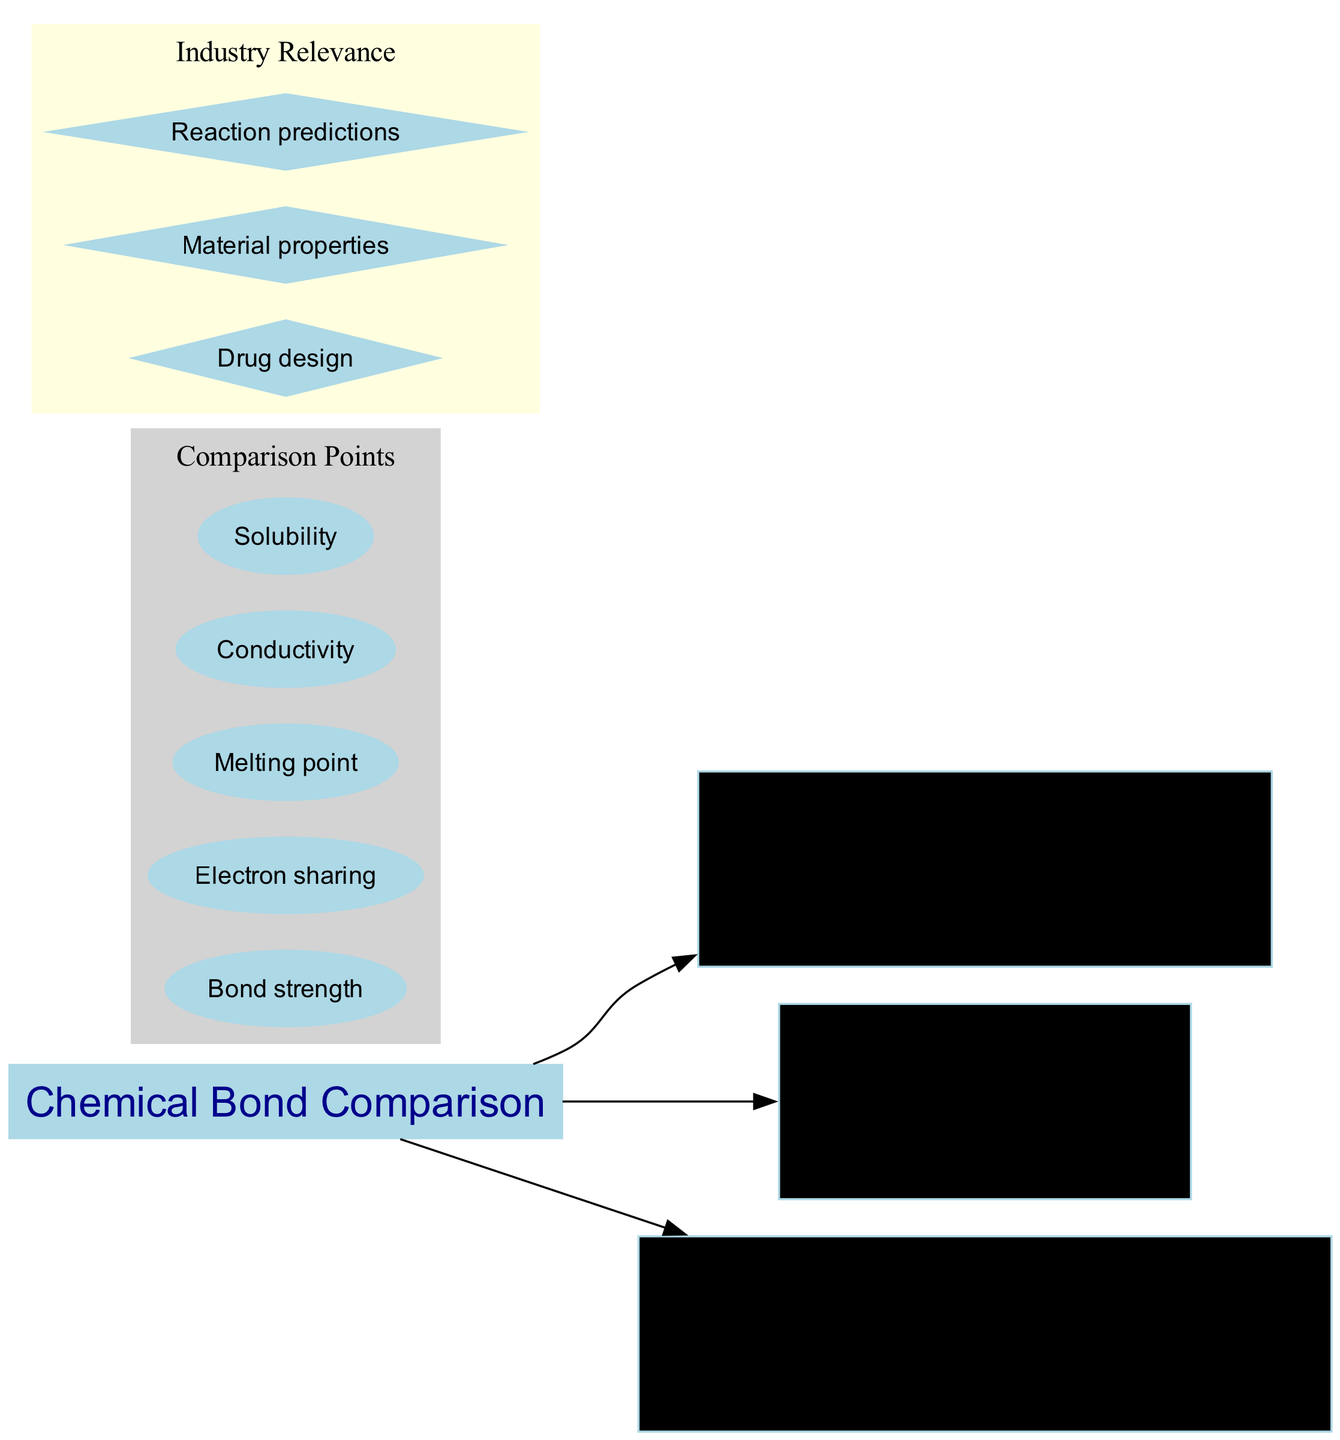What are the three types of chemical bonds listed in the diagram? The diagram explicitly lists three bond types under the "Chemical Bond Comparison" title: Ionic Bond, Covalent Bond, and Hydrogen Bond.
Answer: Ionic Bond, Covalent Bond, Hydrogen Bond Which bond type has the strongest bond strength? By reviewing the bond strength information in the nodes for each bond type, the Ionic Bond is noted as having a "Strong" bond strength, which is stronger than the others.
Answer: Strong What is the electron transfer for Hydrogen Bonds? The diagram states that Hydrogen Bonds have "None" when it comes to electron transfer. This is a direct lookup in the node for Hydrogen Bond.
Answer: None How many comparison points are listed in the diagram? The diagram lists five comparison points in the designated subgraph. This information is found by counting each point noted.
Answer: Five Which bond type has a variable bond strength? From the descriptions provided, the Covalent Bond is specifically labeled as having a "Variable" bond strength. This can be directly referred to in that node.
Answer: Variable What is the example given for Ionic Bond? The diagram indicates that NaCl (table salt) is the example associated with the Ionic Bond, as stated in its respective node.
Answer: NaCl (table salt) Which industry relevance point is associated with Drug design? The diagram lists "Drug design" as one of the industry relevance points. This information can be found in the cluster labeled "Industry Relevance."
Answer: Drug design What type of attraction is described for Hydrogen Bonds? According to the notes provided for Hydrogen Bonds, the type of attraction described is "Attraction between H and electronegative atom." This is indicated in the relevant node.
Answer: Attraction between H and electronegative atom What is the example given for Covalent Bond? The example provided for the Covalent Bond in the diagram is H2O (water), which is explicitly stated in the description of the Covalent Bond.
Answer: H2O (water) 